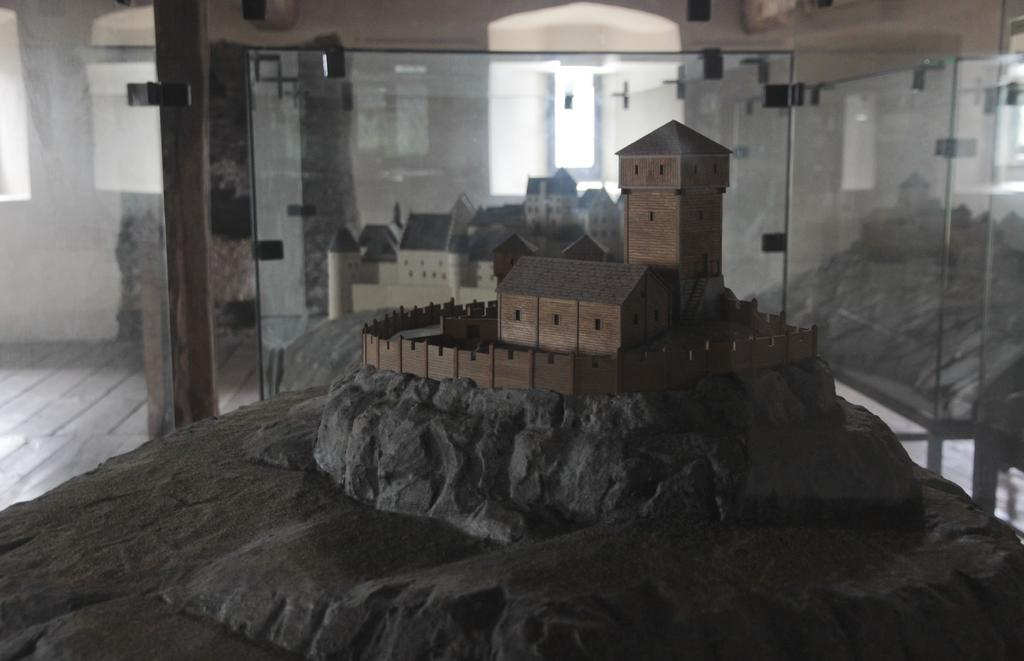What type of structures can be seen in the image? There are buildings in the image. What natural elements are present in the image? There are rocks in the image. What architectural feature is visible in the background of the image? There is a glass door in the background of the image. What else can be seen in the background of the image? There is a wall and other objects in the background of the image. What can be used for viewing the outside environment in the image? There are windows in the image. What surface is at the bottom of the image? There is a floor at the bottom of the image. Can you see any fog in the image? There is no mention of fog in the image, so it cannot be determined if it is present. What type of shelf is visible in the image? There is no mention of a shelf in the image, so it cannot be determined if it is present. 